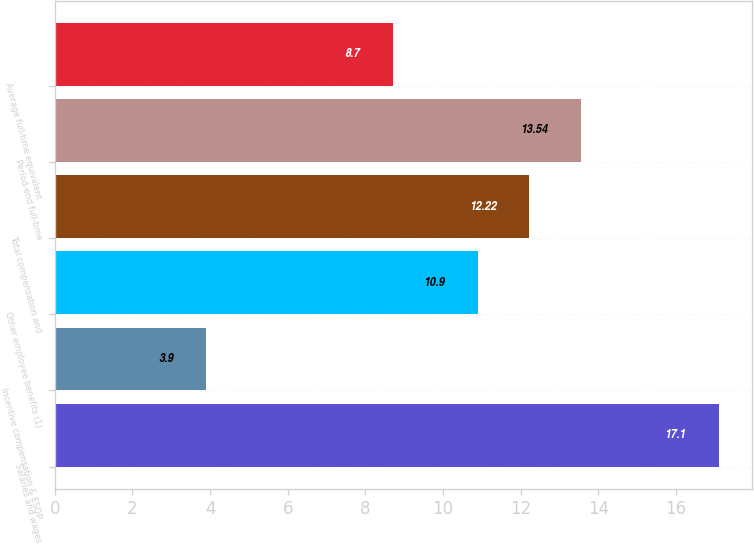Convert chart to OTSL. <chart><loc_0><loc_0><loc_500><loc_500><bar_chart><fcel>Salaries and wages<fcel>Incentive compensation & ESOP<fcel>Other employee benefits (1)<fcel>Total compensation and<fcel>Period-end full-time<fcel>Average full-time equivalent<nl><fcel>17.1<fcel>3.9<fcel>10.9<fcel>12.22<fcel>13.54<fcel>8.7<nl></chart> 